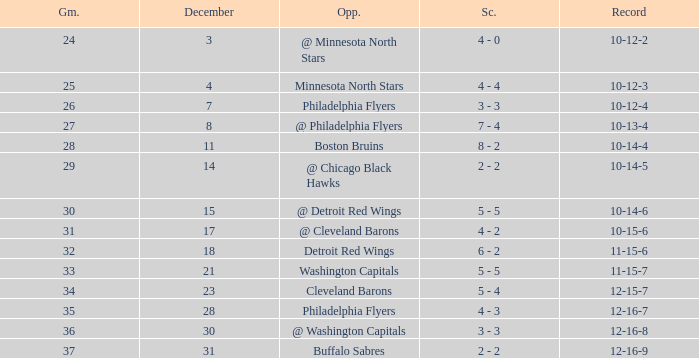What is Record, when Game is "24"? 10-12-2. 